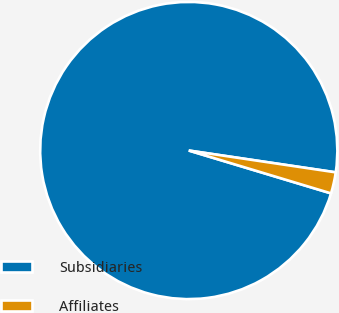<chart> <loc_0><loc_0><loc_500><loc_500><pie_chart><fcel>Subsidiaries<fcel>Affiliates<nl><fcel>97.69%<fcel>2.31%<nl></chart> 